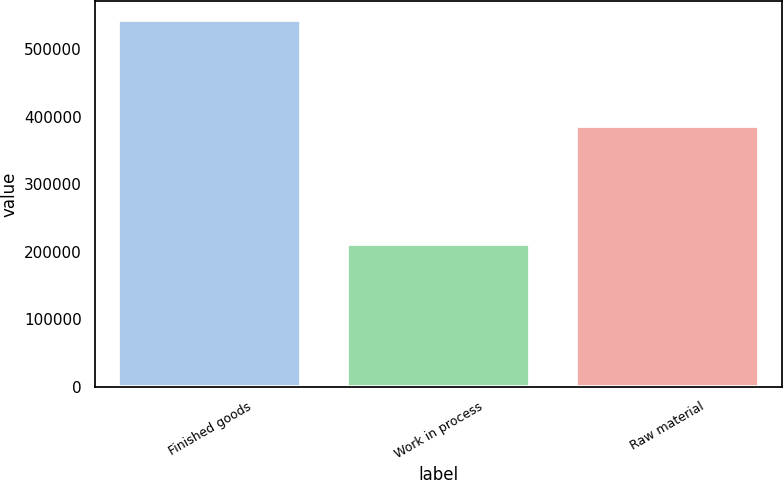<chart> <loc_0><loc_0><loc_500><loc_500><bar_chart><fcel>Finished goods<fcel>Work in process<fcel>Raw material<nl><fcel>543996<fcel>211353<fcel>386960<nl></chart> 